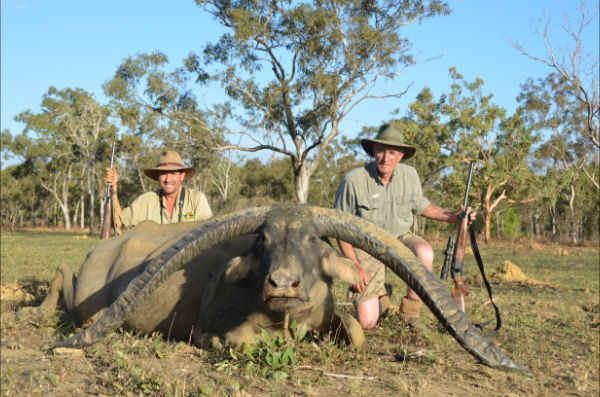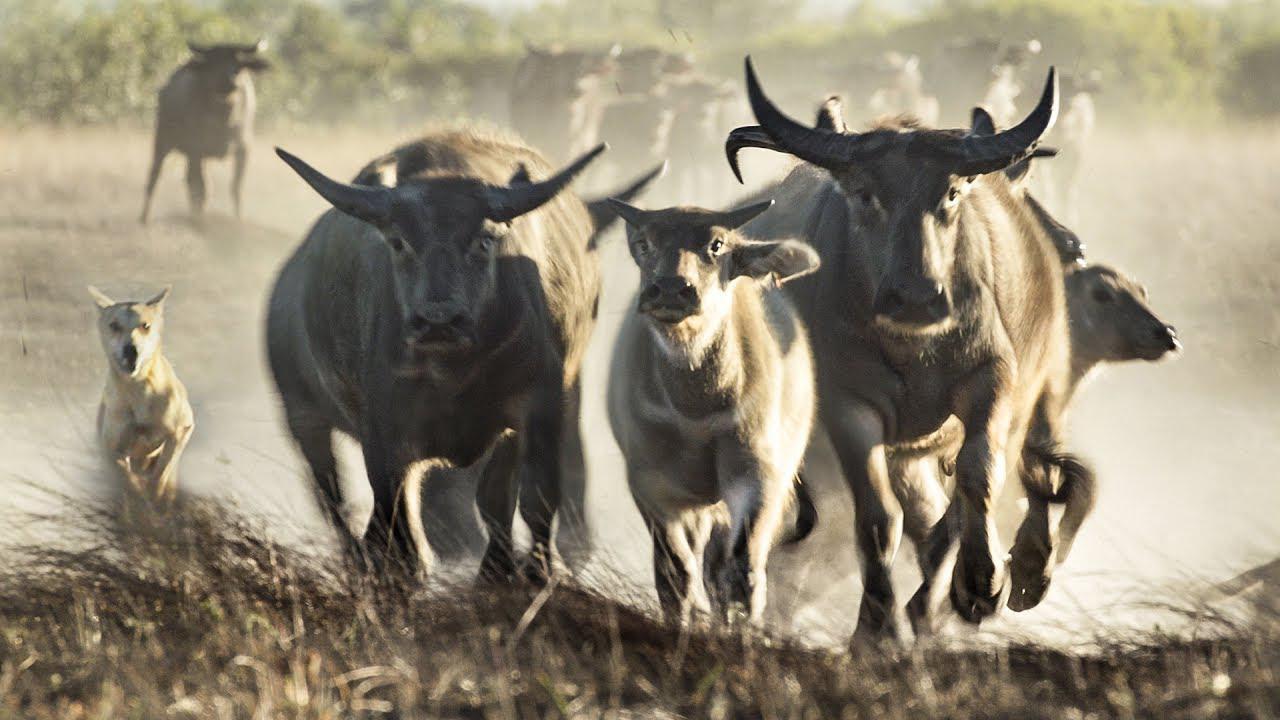The first image is the image on the left, the second image is the image on the right. Evaluate the accuracy of this statement regarding the images: "An image contains at least one person behind a dead water buffalo.". Is it true? Answer yes or no. Yes. The first image is the image on the left, the second image is the image on the right. For the images shown, is this caption "There is at least one human in one of the images near a buffalo." true? Answer yes or no. Yes. 